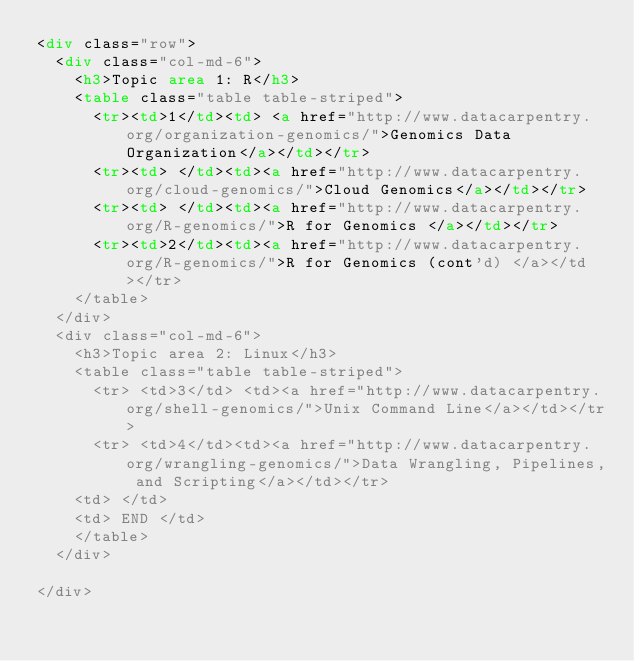<code> <loc_0><loc_0><loc_500><loc_500><_HTML_><div class="row">
  <div class="col-md-6">
    <h3>Topic area 1: R</h3>
    <table class="table table-striped">
      <tr><td>1</td><td> <a href="http://www.datacarpentry.org/organization-genomics/">Genomics Data Organization</a></td></tr>
      <tr><td> </td><td><a href="http://www.datacarpentry.org/cloud-genomics/">Cloud Genomics</a></td></tr>
      <tr><td> </td><td><a href="http://www.datacarpentry.org/R-genomics/">R for Genomics </a></td></tr>
      <tr><td>2</td><td><a href="http://www.datacarpentry.org/R-genomics/">R for Genomics (cont'd) </a></td></tr>
    </table>
  </div>
  <div class="col-md-6">
    <h3>Topic area 2: Linux</h3>
    <table class="table table-striped">
      <tr> <td>3</td> <td><a href="http://www.datacarpentry.org/shell-genomics/">Unix Command Line</a></td></tr>
      <tr> <td>4</td><td><a href="http://www.datacarpentry.org/wrangling-genomics/">Data Wrangling, Pipelines, and Scripting</a></td></tr>
	<td> </td>
	<td> END </td>
    </table>
  </div>

</div>
</code> 